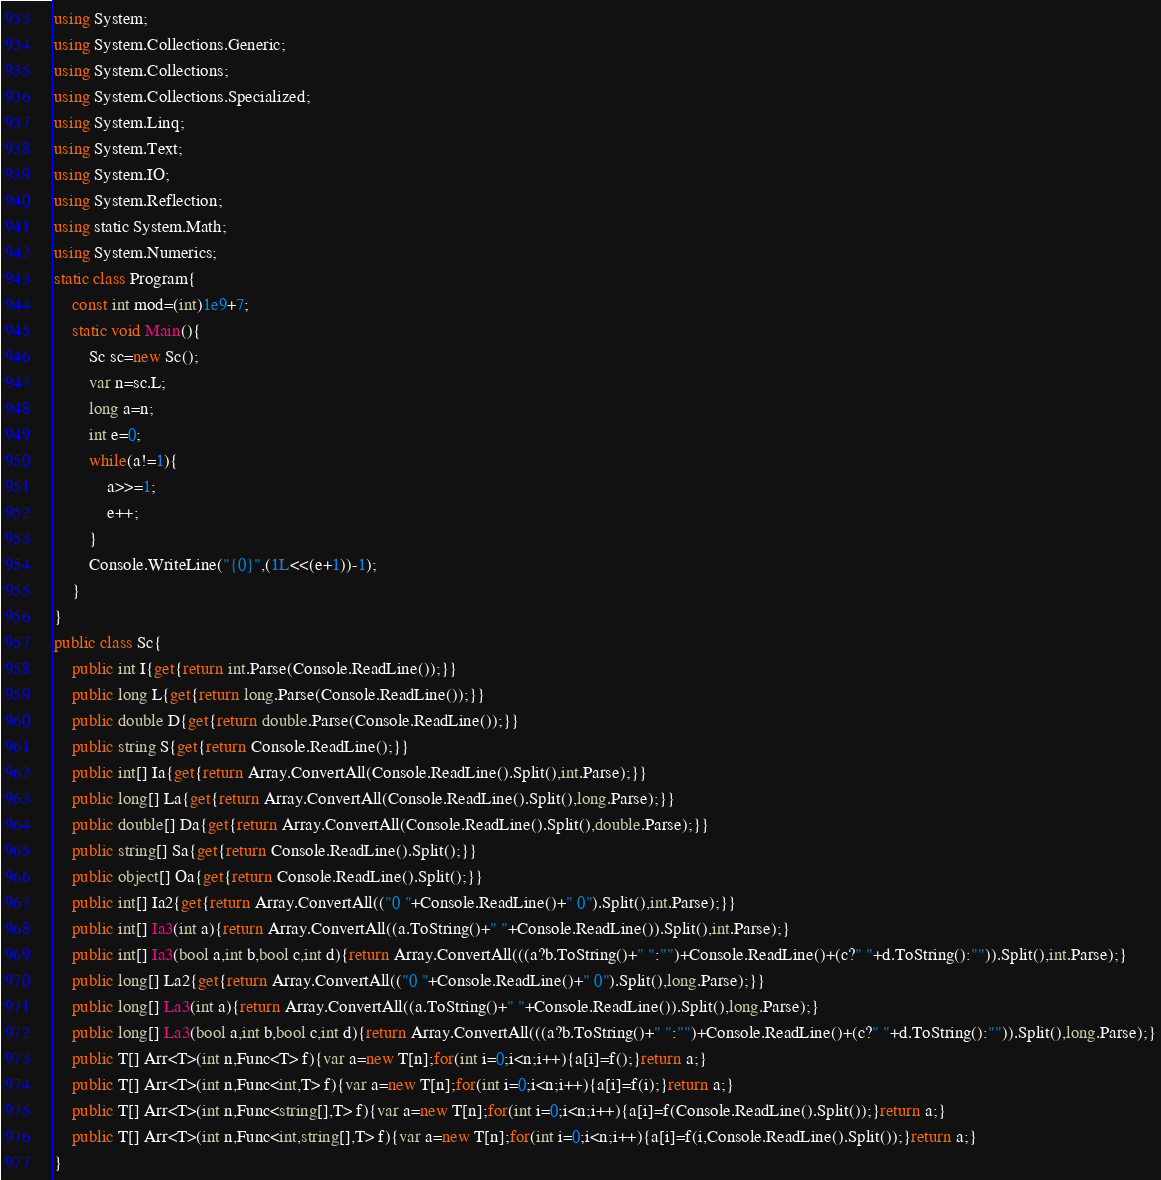Convert code to text. <code><loc_0><loc_0><loc_500><loc_500><_C#_>using System;
using System.Collections.Generic;
using System.Collections;
using System.Collections.Specialized;
using System.Linq;
using System.Text;
using System.IO;
using System.Reflection;
using static System.Math;
using System.Numerics;
static class Program{
	const int mod=(int)1e9+7;
	static void Main(){
		Sc sc=new Sc();
		var n=sc.L;
		long a=n;
		int e=0;
		while(a!=1){
			a>>=1;
			e++;
		}
		Console.WriteLine("{0}",(1L<<(e+1))-1);
	}
}
public class Sc{
	public int I{get{return int.Parse(Console.ReadLine());}}
	public long L{get{return long.Parse(Console.ReadLine());}}
	public double D{get{return double.Parse(Console.ReadLine());}}
	public string S{get{return Console.ReadLine();}}
	public int[] Ia{get{return Array.ConvertAll(Console.ReadLine().Split(),int.Parse);}}
	public long[] La{get{return Array.ConvertAll(Console.ReadLine().Split(),long.Parse);}}
	public double[] Da{get{return Array.ConvertAll(Console.ReadLine().Split(),double.Parse);}}
	public string[] Sa{get{return Console.ReadLine().Split();}}
	public object[] Oa{get{return Console.ReadLine().Split();}}
	public int[] Ia2{get{return Array.ConvertAll(("0 "+Console.ReadLine()+" 0").Split(),int.Parse);}}
	public int[] Ia3(int a){return Array.ConvertAll((a.ToString()+" "+Console.ReadLine()).Split(),int.Parse);}
	public int[] Ia3(bool a,int b,bool c,int d){return Array.ConvertAll(((a?b.ToString()+" ":"")+Console.ReadLine()+(c?" "+d.ToString():"")).Split(),int.Parse);}
	public long[] La2{get{return Array.ConvertAll(("0 "+Console.ReadLine()+" 0").Split(),long.Parse);}}
	public long[] La3(int a){return Array.ConvertAll((a.ToString()+" "+Console.ReadLine()).Split(),long.Parse);}
	public long[] La3(bool a,int b,bool c,int d){return Array.ConvertAll(((a?b.ToString()+" ":"")+Console.ReadLine()+(c?" "+d.ToString():"")).Split(),long.Parse);}
	public T[] Arr<T>(int n,Func<T> f){var a=new T[n];for(int i=0;i<n;i++){a[i]=f();}return a;}
	public T[] Arr<T>(int n,Func<int,T> f){var a=new T[n];for(int i=0;i<n;i++){a[i]=f(i);}return a;}
	public T[] Arr<T>(int n,Func<string[],T> f){var a=new T[n];for(int i=0;i<n;i++){a[i]=f(Console.ReadLine().Split());}return a;}
	public T[] Arr<T>(int n,Func<int,string[],T> f){var a=new T[n];for(int i=0;i<n;i++){a[i]=f(i,Console.ReadLine().Split());}return a;}
}</code> 